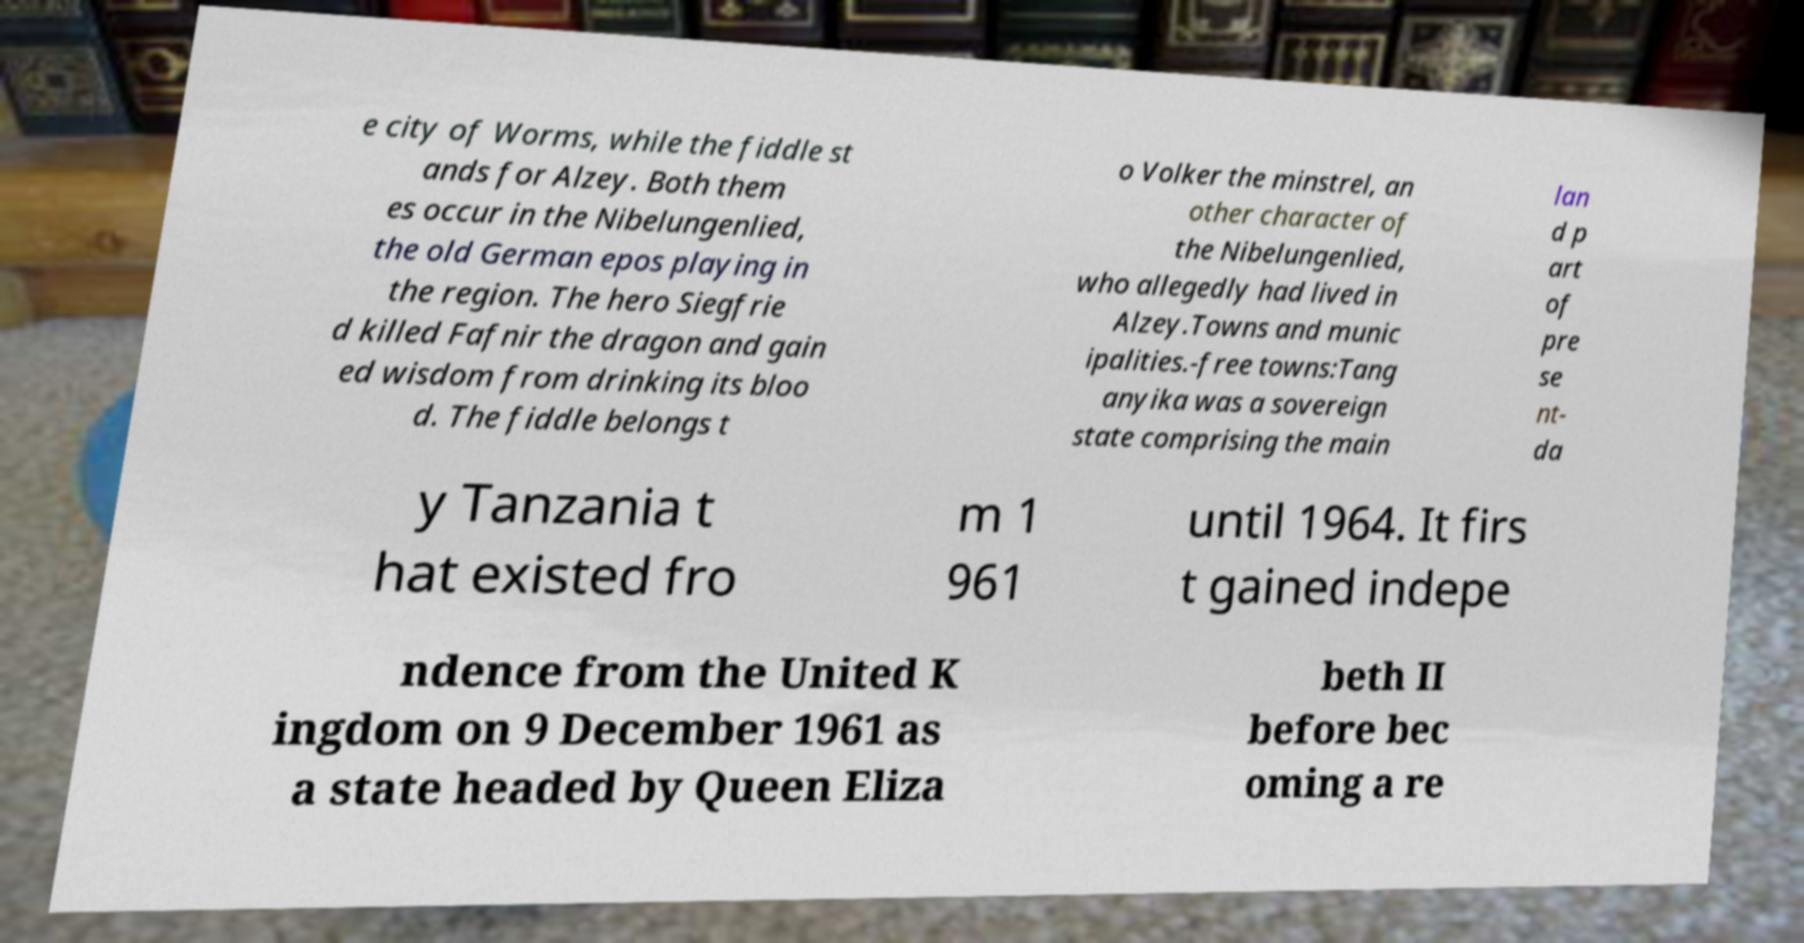For documentation purposes, I need the text within this image transcribed. Could you provide that? e city of Worms, while the fiddle st ands for Alzey. Both them es occur in the Nibelungenlied, the old German epos playing in the region. The hero Siegfrie d killed Fafnir the dragon and gain ed wisdom from drinking its bloo d. The fiddle belongs t o Volker the minstrel, an other character of the Nibelungenlied, who allegedly had lived in Alzey.Towns and munic ipalities.-free towns:Tang anyika was a sovereign state comprising the main lan d p art of pre se nt- da y Tanzania t hat existed fro m 1 961 until 1964. It firs t gained indepe ndence from the United K ingdom on 9 December 1961 as a state headed by Queen Eliza beth II before bec oming a re 